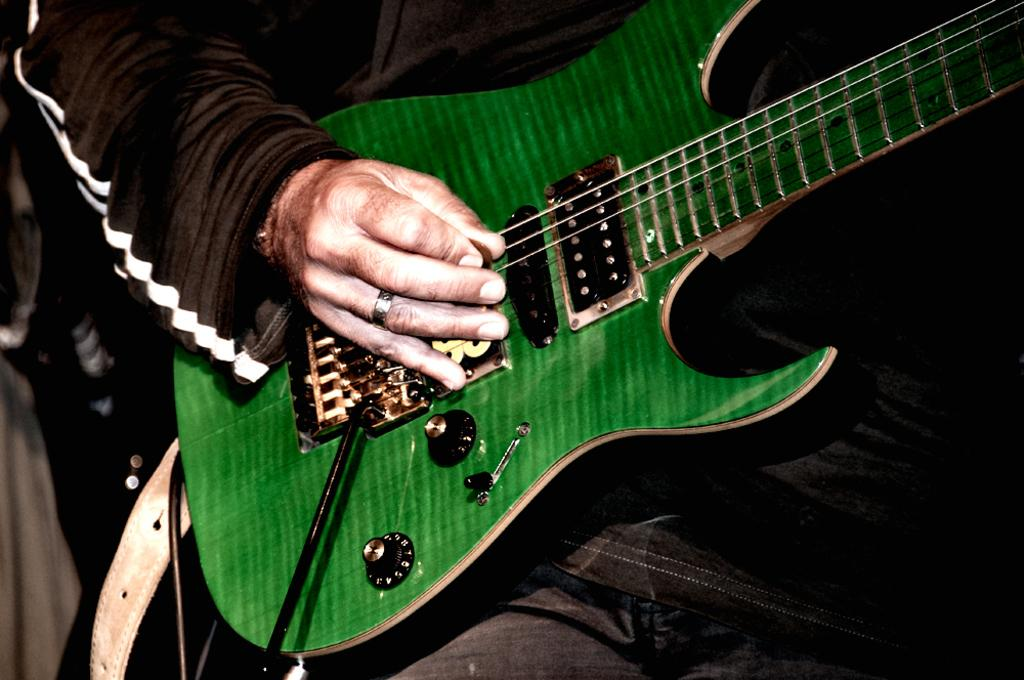What is the main subject of the image? The main subject of the image is a man. What is the man doing in the image? The man is playing a guitar in the image. What color is the lip of the guitar in the image? There is no mention of a guitar's lip in the provided facts, and the image does not show any visible lip on the guitar. 